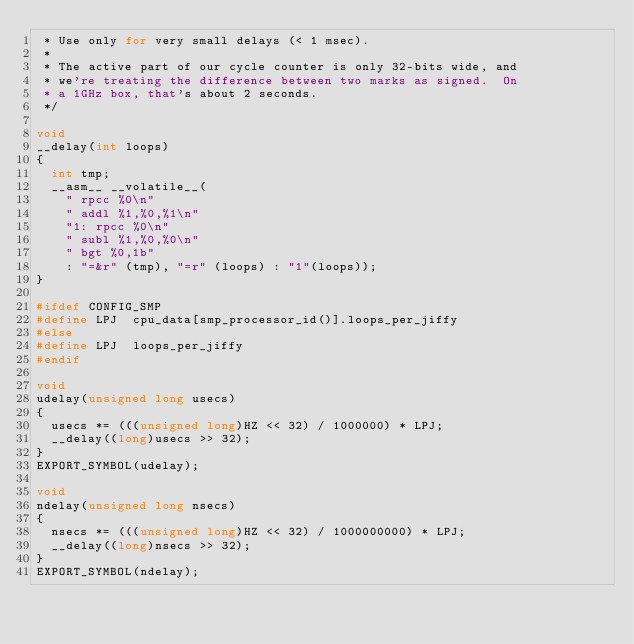Convert code to text. <code><loc_0><loc_0><loc_500><loc_500><_C_> * Use only for very small delays (< 1 msec). 
 *
 * The active part of our cycle counter is only 32-bits wide, and
 * we're treating the difference between two marks as signed.  On
 * a 1GHz box, that's about 2 seconds.
 */

void
__delay(int loops)
{
	int tmp;
	__asm__ __volatile__(
		"	rpcc %0\n"
		"	addl %1,%0,%1\n"
		"1:	rpcc %0\n"
		"	subl %1,%0,%0\n"
		"	bgt %0,1b"
		: "=&r" (tmp), "=r" (loops) : "1"(loops));
}

#ifdef CONFIG_SMP
#define LPJ	 cpu_data[smp_processor_id()].loops_per_jiffy
#else
#define LPJ	 loops_per_jiffy
#endif

void
udelay(unsigned long usecs)
{
	usecs *= (((unsigned long)HZ << 32) / 1000000) * LPJ;
	__delay((long)usecs >> 32);
}
EXPORT_SYMBOL(udelay);

void
ndelay(unsigned long nsecs)
{
	nsecs *= (((unsigned long)HZ << 32) / 1000000000) * LPJ;
	__delay((long)nsecs >> 32);
}
EXPORT_SYMBOL(ndelay);
</code> 